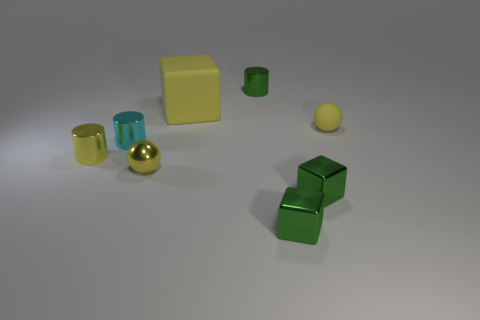Is the color of the tiny shiny sphere the same as the small rubber object?
Ensure brevity in your answer.  Yes. Is there any other thing that has the same size as the yellow rubber block?
Offer a very short reply. No. What number of things are small metallic balls or green objects that are behind the large yellow thing?
Keep it short and to the point. 2. Are there any small green matte cubes?
Keep it short and to the point. No. How many cylinders are the same color as the matte block?
Your answer should be compact. 1. What material is the cylinder that is the same color as the big object?
Your answer should be very brief. Metal. There is a block that is behind the tiny yellow ball to the left of the large yellow cube; what is its size?
Provide a succinct answer. Large. Are there any small cyan cylinders made of the same material as the cyan thing?
Provide a short and direct response. No. There is a cyan thing that is the same size as the yellow cylinder; what is it made of?
Your response must be concise. Metal. Does the tiny ball on the left side of the big yellow thing have the same color as the sphere on the right side of the large matte thing?
Your response must be concise. Yes. 